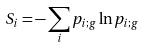Convert formula to latex. <formula><loc_0><loc_0><loc_500><loc_500>S _ { i } = - \sum _ { i } p _ { i ; g } \ln p _ { i ; g }</formula> 